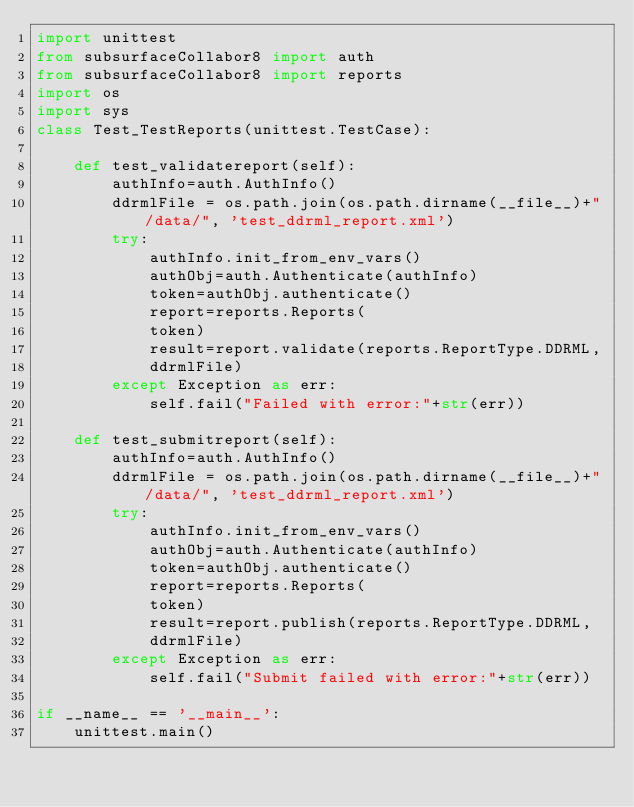<code> <loc_0><loc_0><loc_500><loc_500><_Python_>import unittest
from subsurfaceCollabor8 import auth
from subsurfaceCollabor8 import reports
import os
import sys
class Test_TestReports(unittest.TestCase):

    def test_validatereport(self):
        authInfo=auth.AuthInfo()
        ddrmlFile = os.path.join(os.path.dirname(__file__)+"/data/", 'test_ddrml_report.xml')
        try:
            authInfo.init_from_env_vars()
            authObj=auth.Authenticate(authInfo) 
            token=authObj.authenticate()
            report=reports.Reports(
            token)
            result=report.validate(reports.ReportType.DDRML,
            ddrmlFile)
        except Exception as err:
            self.fail("Failed with error:"+str(err)) 
             
    def test_submitreport(self):
        authInfo=auth.AuthInfo()
        ddrmlFile = os.path.join(os.path.dirname(__file__)+"/data/", 'test_ddrml_report.xml')
        try:
            authInfo.init_from_env_vars()
            authObj=auth.Authenticate(authInfo) 
            token=authObj.authenticate()
            report=reports.Reports(
            token)
            result=report.publish(reports.ReportType.DDRML,
            ddrmlFile)
        except Exception as err:
            self.fail("Submit failed with error:"+str(err)) 

if __name__ == '__main__':
    unittest.main()</code> 